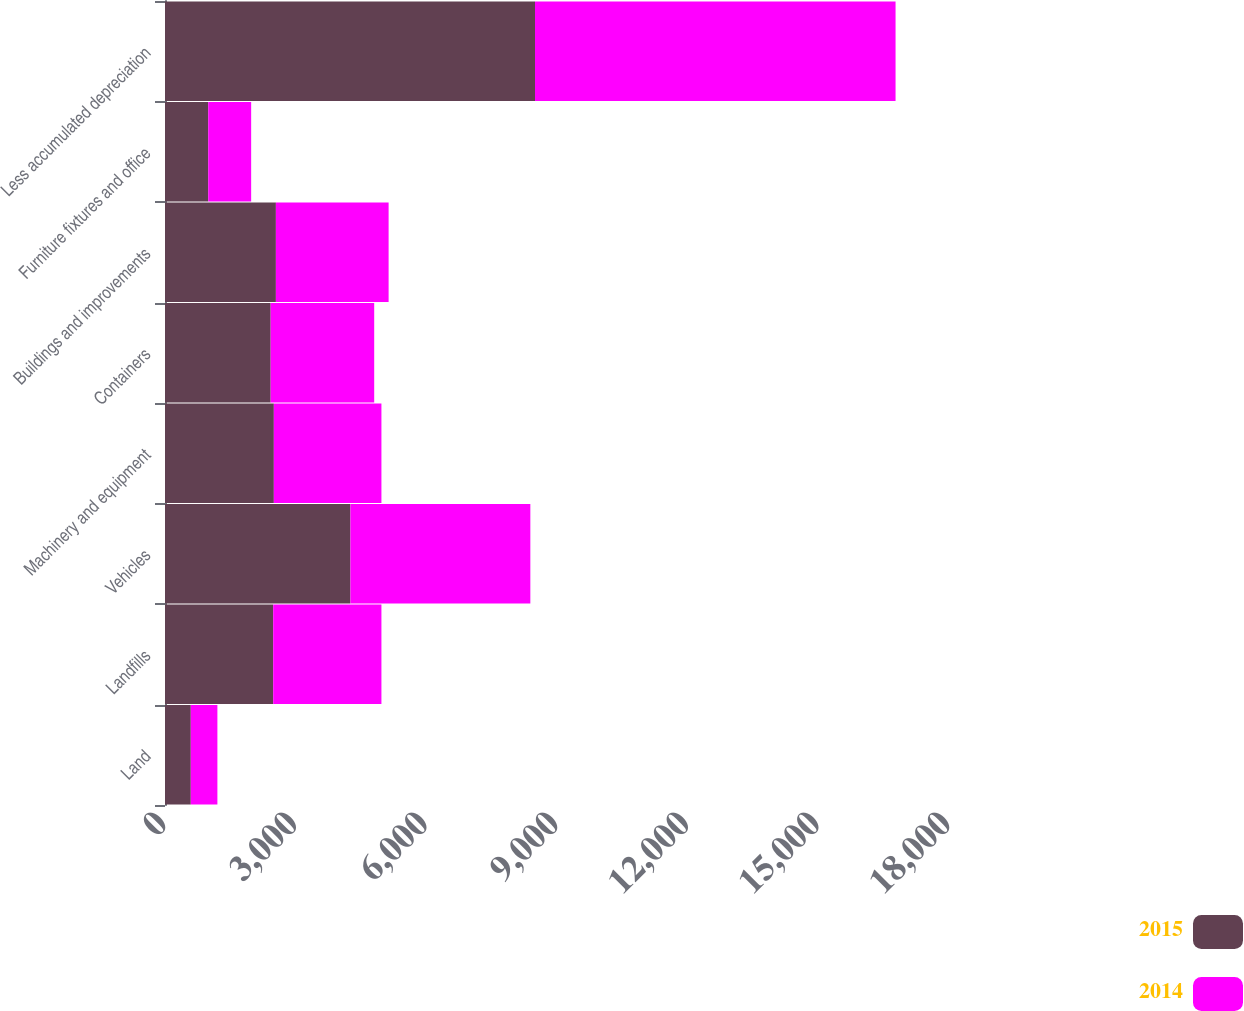Convert chart to OTSL. <chart><loc_0><loc_0><loc_500><loc_500><stacked_bar_chart><ecel><fcel>Land<fcel>Landfills<fcel>Vehicles<fcel>Machinery and equipment<fcel>Containers<fcel>Buildings and improvements<fcel>Furniture fixtures and office<fcel>Less accumulated depreciation<nl><fcel>2015<fcel>592<fcel>2484.5<fcel>4257<fcel>2499<fcel>2426<fcel>2546<fcel>993<fcel>8495<nl><fcel>2014<fcel>611<fcel>2484.5<fcel>4131<fcel>2470<fcel>2377<fcel>2588<fcel>985<fcel>8278<nl></chart> 